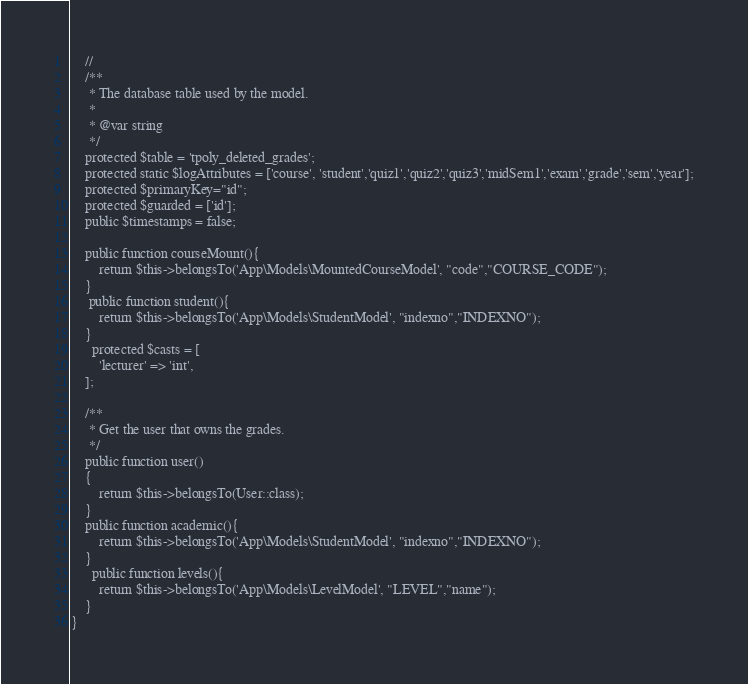<code> <loc_0><loc_0><loc_500><loc_500><_PHP_>    //
    /**
     * The database table used by the model.
     *
     * @var string
     */
    protected $table = 'tpoly_deleted_grades';
    protected static $logAttributes = ['course', 'student','quiz1','quiz2','quiz3','midSem1','exam','grade','sem','year'];
    protected $primaryKey="id";
    protected $guarded = ['id'];
    public $timestamps = false;
    
    public function courseMount(){
        return $this->belongsTo('App\Models\MountedCourseModel', "code","COURSE_CODE");
    }
     public function student(){
        return $this->belongsTo('App\Models\StudentModel', "indexno","INDEXNO");
    }
      protected $casts = [
        'lecturer' => 'int',
    ];

    /**
     * Get the user that owns the grades.
     */
    public function user()
    {
        return $this->belongsTo(User::class);
    }
    public function academic(){
        return $this->belongsTo('App\Models\StudentModel', "indexno","INDEXNO");
    }
      public function levels(){
        return $this->belongsTo('App\Models\LevelModel', "LEVEL","name");
    }
}
</code> 